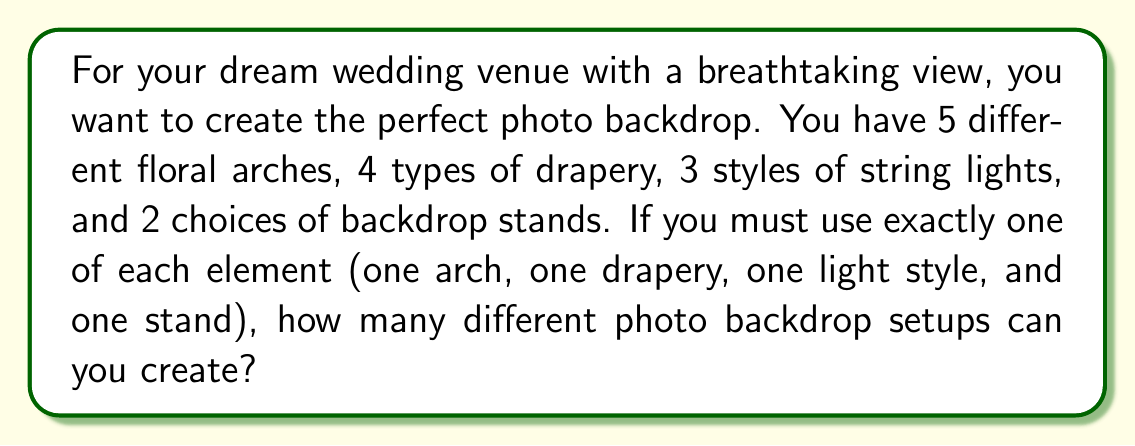Could you help me with this problem? Let's approach this step-by-step using the multiplication principle of counting:

1) For each element of the photo backdrop, we have a choice to make:
   - 5 choices for floral arches
   - 4 choices for drapery
   - 3 choices for string lights
   - 2 choices for backdrop stands

2) According to the multiplication principle, if we have a sequence of independent choices, the total number of possible outcomes is the product of the number of possibilities for each choice.

3) In this case, for each backdrop setup, we make one choice from each category. These choices are independent of each other.

4) Therefore, the total number of possible backdrop setups is:

   $$ 5 \times 4 \times 3 \times 2 $$

5) Calculating this:
   $$ 5 \times 4 \times 3 \times 2 = 120 $$

Thus, there are 120 different possible photo backdrop setups.
Answer: 120 